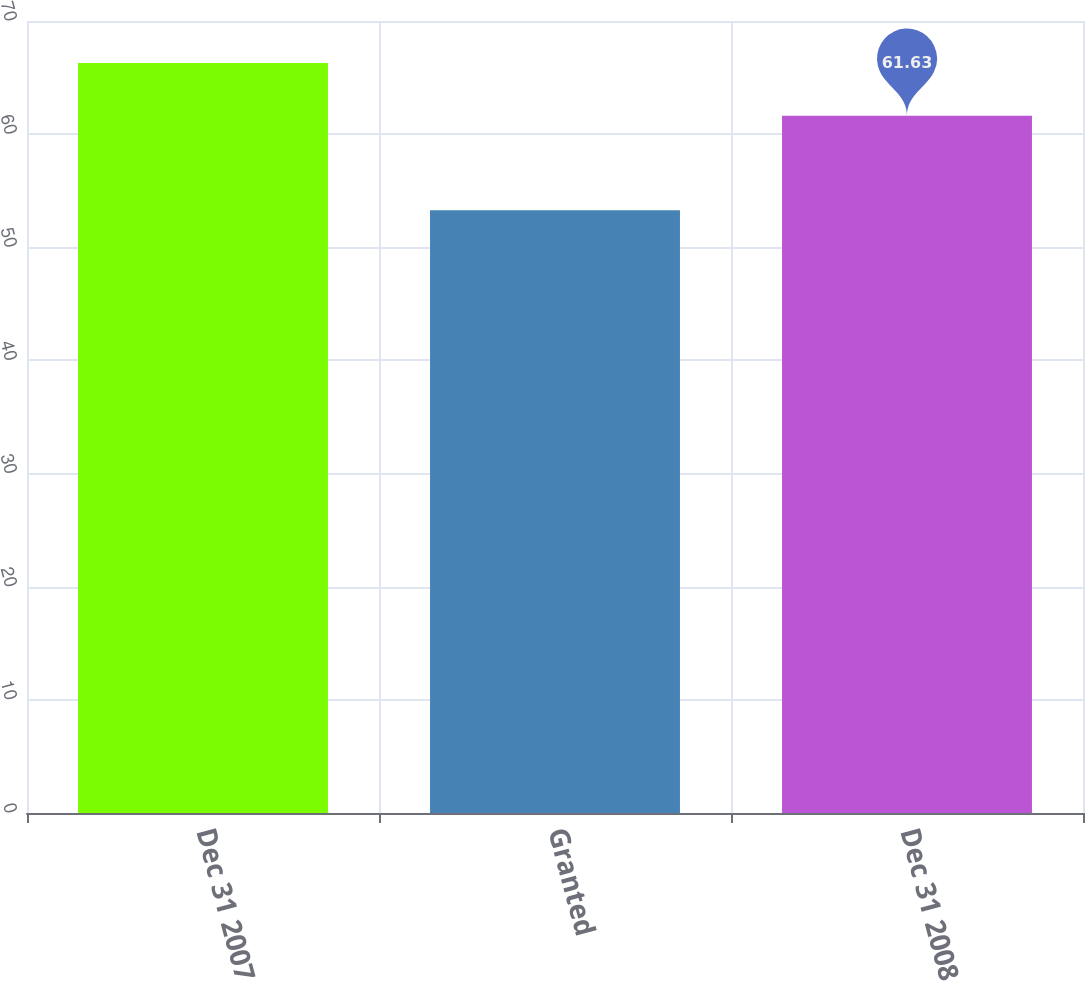<chart> <loc_0><loc_0><loc_500><loc_500><bar_chart><fcel>Dec 31 2007<fcel>Granted<fcel>Dec 31 2008<nl><fcel>66.28<fcel>53.27<fcel>61.63<nl></chart> 